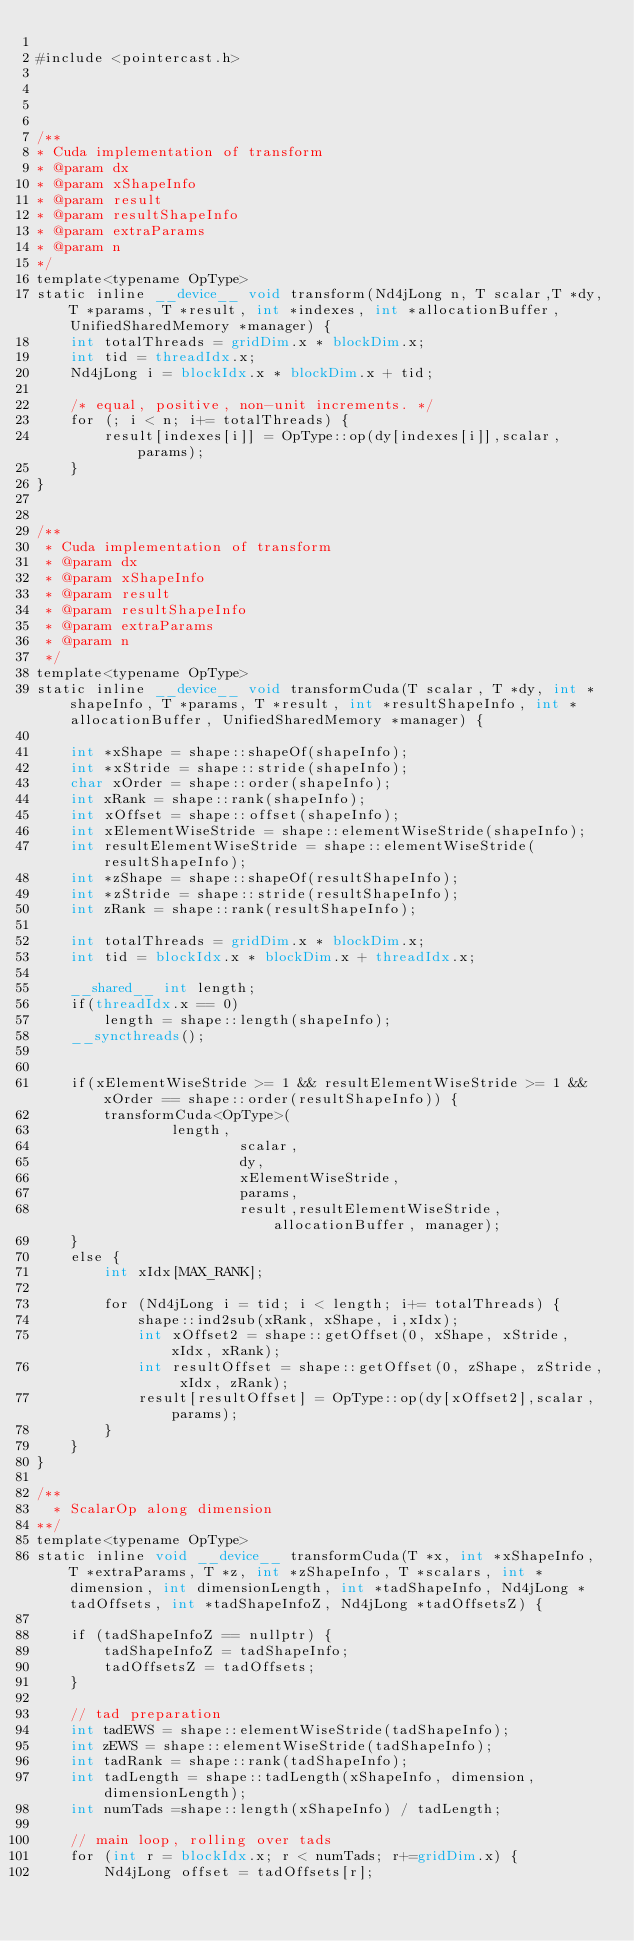<code> <loc_0><loc_0><loc_500><loc_500><_Cuda_>
#include <pointercast.h>




/**
* Cuda implementation of transform
* @param dx
* @param xShapeInfo
* @param result
* @param resultShapeInfo
* @param extraParams
* @param n
*/
template<typename OpType>
static inline __device__ void transform(Nd4jLong n, T scalar,T *dy,T *params, T *result, int *indexes, int *allocationBuffer, UnifiedSharedMemory *manager) {
    int totalThreads = gridDim.x * blockDim.x;
    int tid = threadIdx.x;
    Nd4jLong i = blockIdx.x * blockDim.x + tid;

    /* equal, positive, non-unit increments. */
    for (; i < n; i+= totalThreads) {
        result[indexes[i]] = OpType::op(dy[indexes[i]],scalar, params);
    }
}


/**
 * Cuda implementation of transform
 * @param dx
 * @param xShapeInfo
 * @param result
 * @param resultShapeInfo
 * @param extraParams
 * @param n
 */
template<typename OpType>
static inline __device__ void transformCuda(T scalar, T *dy, int *shapeInfo, T *params, T *result, int *resultShapeInfo, int *allocationBuffer, UnifiedSharedMemory *manager) {

    int *xShape = shape::shapeOf(shapeInfo);
    int *xStride = shape::stride(shapeInfo);
    char xOrder = shape::order(shapeInfo);
    int xRank = shape::rank(shapeInfo);
    int xOffset = shape::offset(shapeInfo);
    int xElementWiseStride = shape::elementWiseStride(shapeInfo);
    int resultElementWiseStride = shape::elementWiseStride(resultShapeInfo);
    int *zShape = shape::shapeOf(resultShapeInfo);
    int *zStride = shape::stride(resultShapeInfo);
    int zRank = shape::rank(resultShapeInfo);

    int totalThreads = gridDim.x * blockDim.x;
    int tid = blockIdx.x * blockDim.x + threadIdx.x;

    __shared__ int length;
    if(threadIdx.x == 0)
        length = shape::length(shapeInfo);
    __syncthreads();


    if(xElementWiseStride >= 1 && resultElementWiseStride >= 1 && xOrder == shape::order(resultShapeInfo)) {
        transformCuda<OpType>(
                length,
                        scalar,
                        dy,
                        xElementWiseStride,
                        params,
                        result,resultElementWiseStride, allocationBuffer, manager);
    }
    else {
        int xIdx[MAX_RANK];

        for (Nd4jLong i = tid; i < length; i+= totalThreads) {
            shape::ind2sub(xRank, xShape, i,xIdx);
            int xOffset2 = shape::getOffset(0, xShape, xStride, xIdx, xRank);
            int resultOffset = shape::getOffset(0, zShape, zStride, xIdx, zRank);
            result[resultOffset] = OpType::op(dy[xOffset2],scalar, params);
        }
    }
}

/**
  * ScalarOp along dimension
**/
template<typename OpType>
static inline void __device__ transformCuda(T *x, int *xShapeInfo, T *extraParams, T *z, int *zShapeInfo, T *scalars, int *dimension, int dimensionLength, int *tadShapeInfo, Nd4jLong *tadOffsets, int *tadShapeInfoZ, Nd4jLong *tadOffsetsZ) {

    if (tadShapeInfoZ == nullptr) {
        tadShapeInfoZ = tadShapeInfo;
        tadOffsetsZ = tadOffsets;
    }

    // tad preparation
    int tadEWS = shape::elementWiseStride(tadShapeInfo);
    int zEWS = shape::elementWiseStride(tadShapeInfo);
    int tadRank = shape::rank(tadShapeInfo);
    int tadLength = shape::tadLength(xShapeInfo, dimension, dimensionLength);
    int numTads =shape::length(xShapeInfo) / tadLength;

    // main loop, rolling over tads
    for (int r = blockIdx.x; r < numTads; r+=gridDim.x) {
        Nd4jLong offset = tadOffsets[r];</code> 